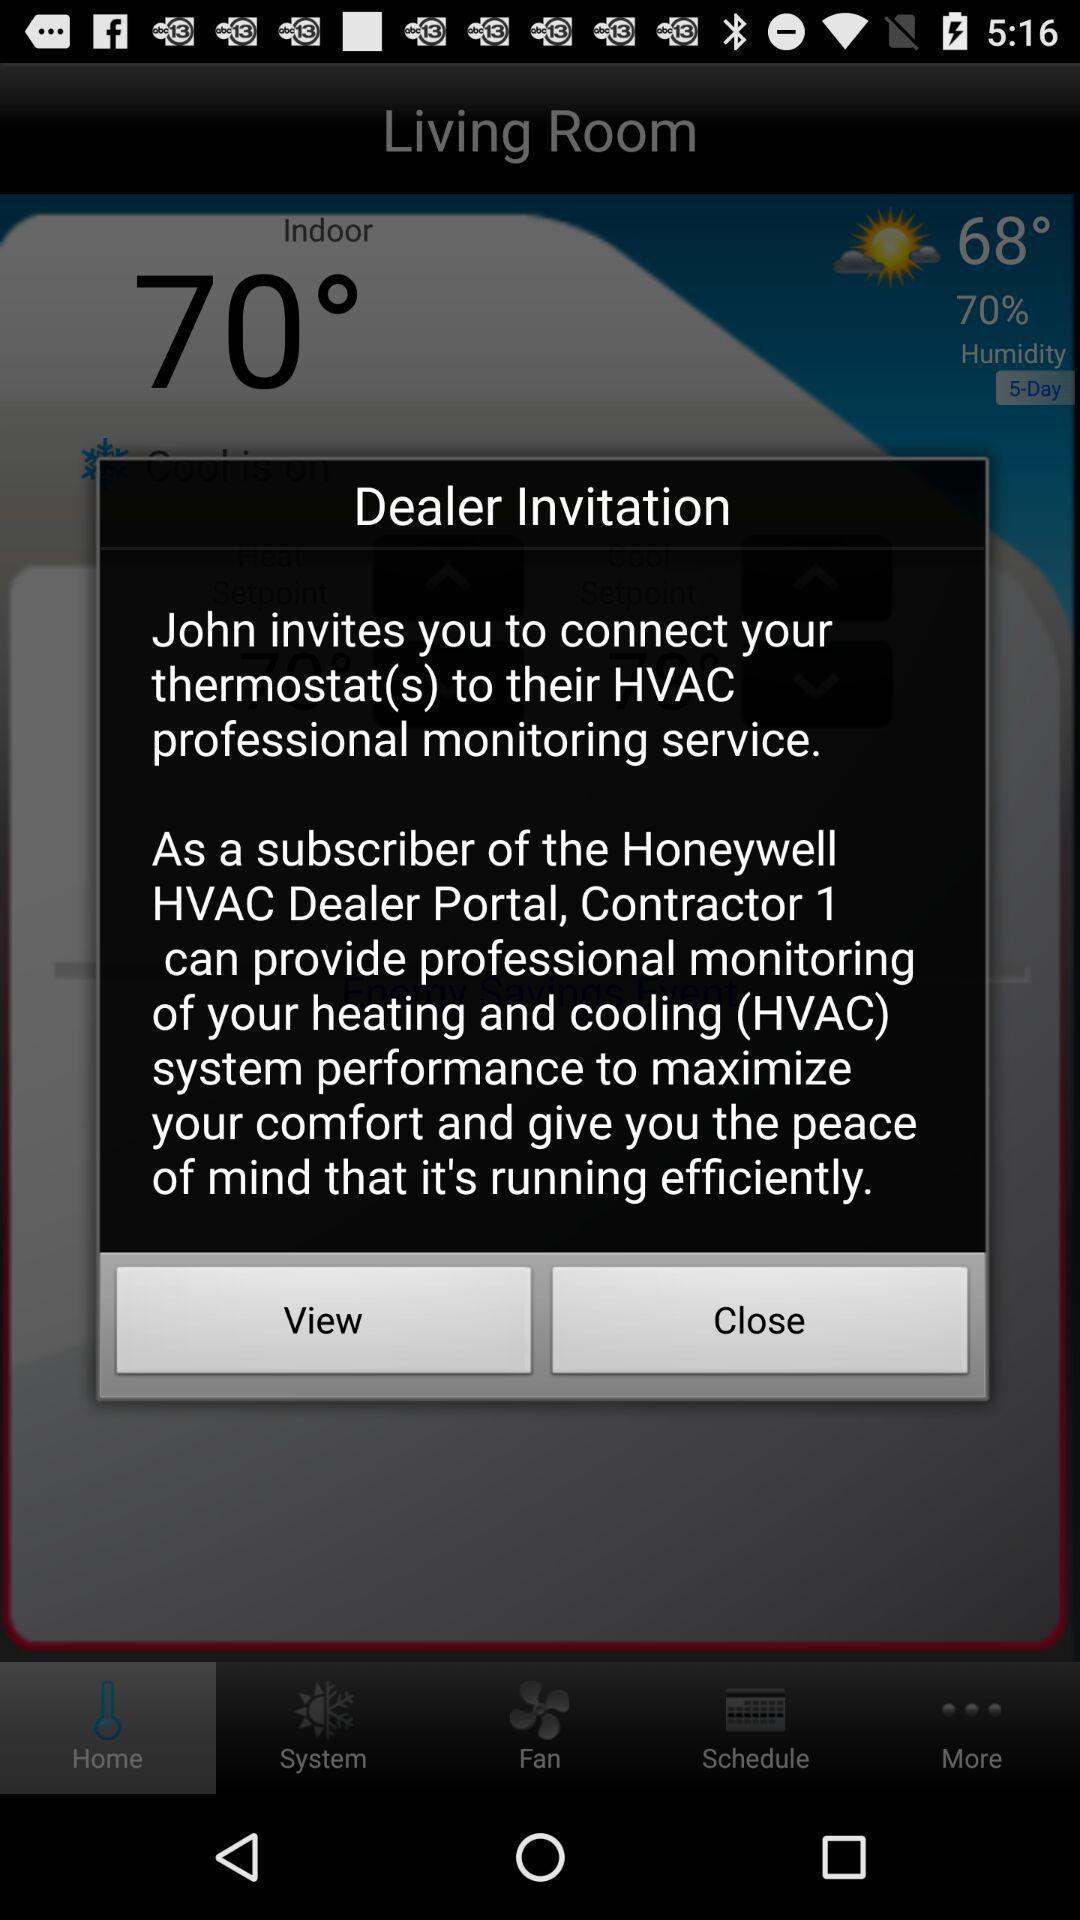Describe the visual elements of this screenshot. Popup showing with view and close option. 